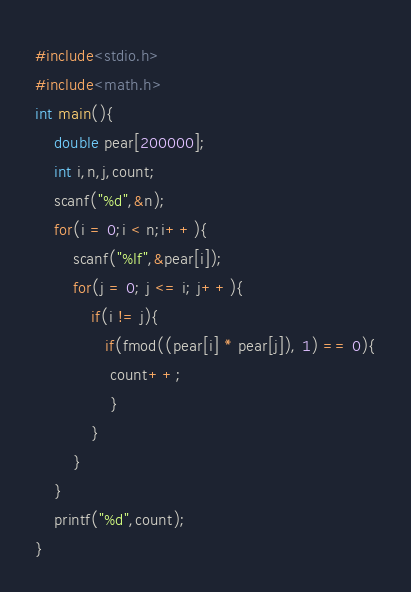Convert code to text. <code><loc_0><loc_0><loc_500><loc_500><_C_>#include<stdio.h>
#include<math.h>
int main(){
	double pear[200000];
	int i,n,j,count;
	scanf("%d",&n);
	for(i = 0;i < n;i++){
		scanf("%lf",&pear[i]);
		for(j = 0; j <= i; j++){
			if(i != j){
			   if(fmod((pear[i] * pear[j]), 1) == 0){
				count++;
		     	}
			}
		}
	}
	printf("%d",count);
}</code> 